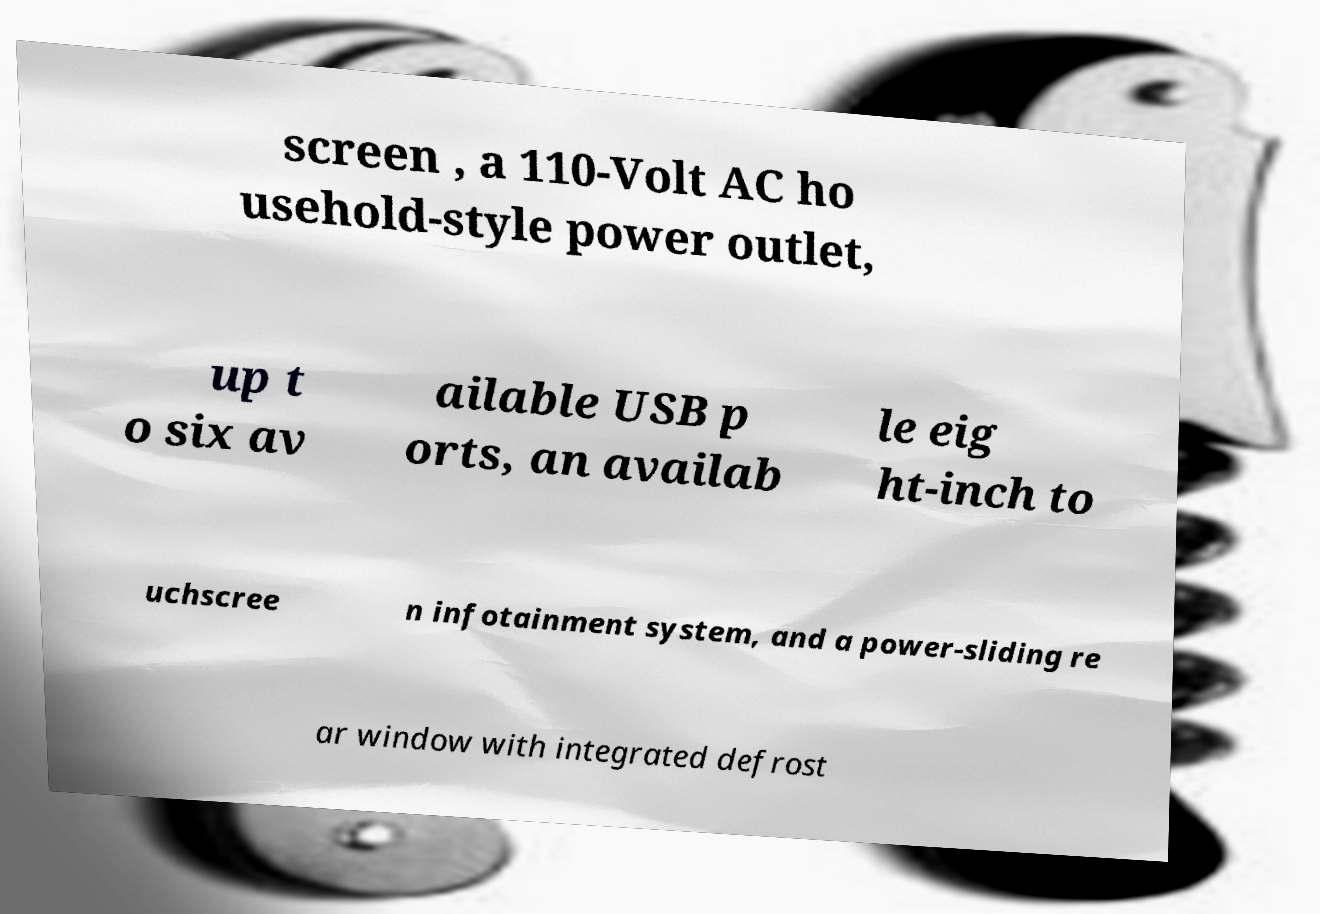I need the written content from this picture converted into text. Can you do that? screen , a 110-Volt AC ho usehold-style power outlet, up t o six av ailable USB p orts, an availab le eig ht-inch to uchscree n infotainment system, and a power-sliding re ar window with integrated defrost 